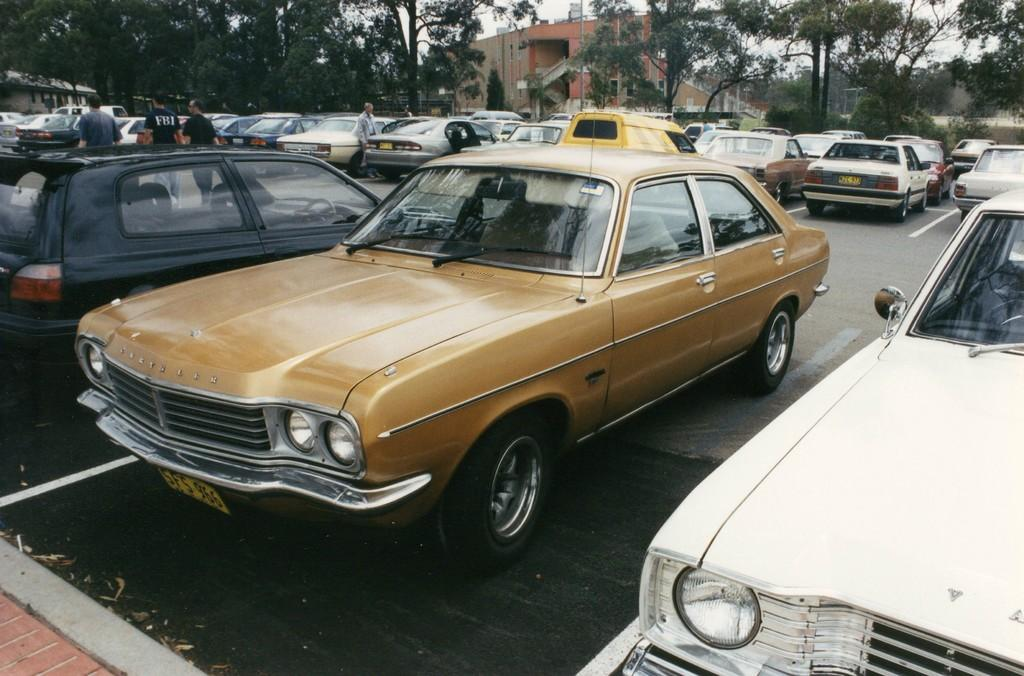What can be seen on the road in the image? There are cars parked on the road in the image. What are the people near the cars doing? There are people standing beside the cars in the image. What can be seen in the distance in the image? There are trees and buildings visible in the background of the image. What type of pet is sitting on the roof of the car in the image? There is no pet visible on the roof of the car in the image. What part of the human body can be seen interacting with the car in the image? There is no human body visible interacting with the car in the image; only people standing beside the cars are present. 